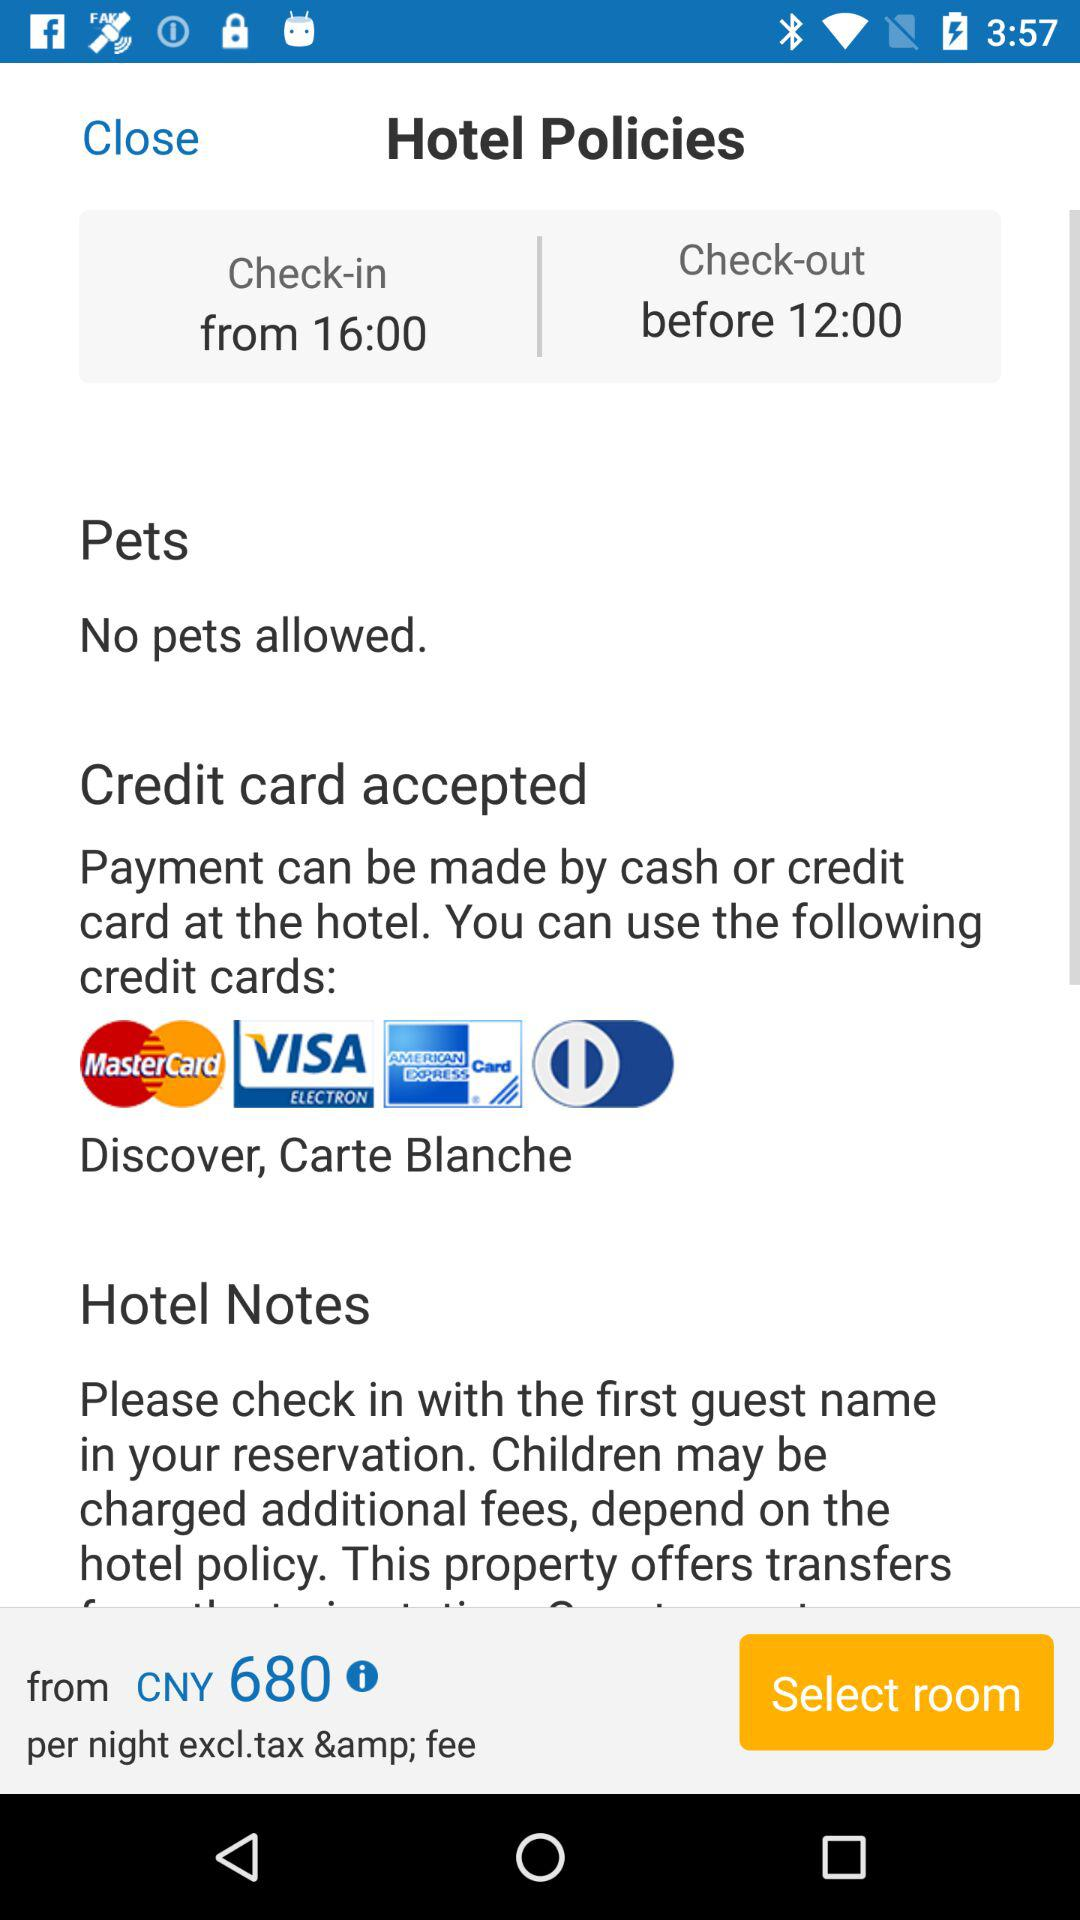What are the payment options available at the hotel? The available payment options are "cash" and "credit card". 